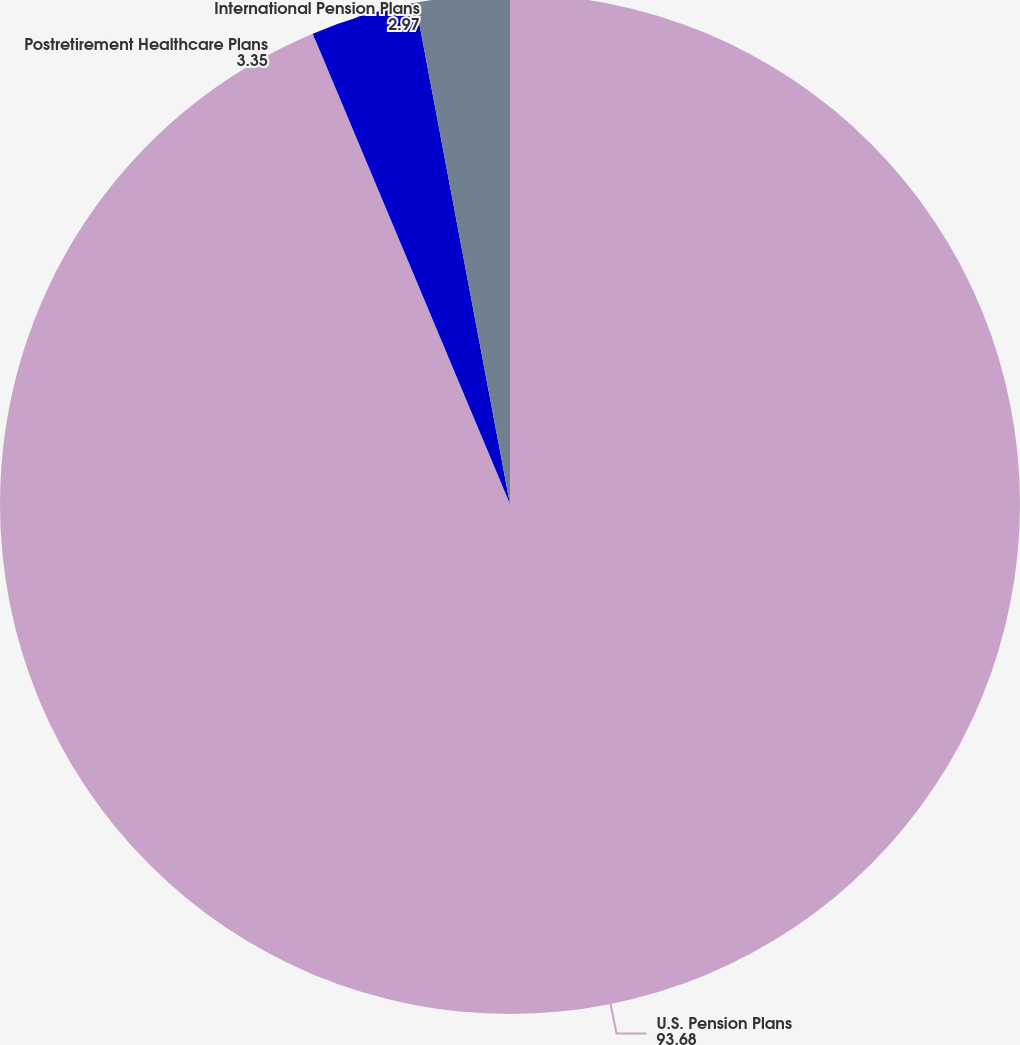Convert chart. <chart><loc_0><loc_0><loc_500><loc_500><pie_chart><fcel>U.S. Pension Plans<fcel>Postretirement Healthcare Plans<fcel>International Pension Plans<nl><fcel>93.68%<fcel>3.35%<fcel>2.97%<nl></chart> 